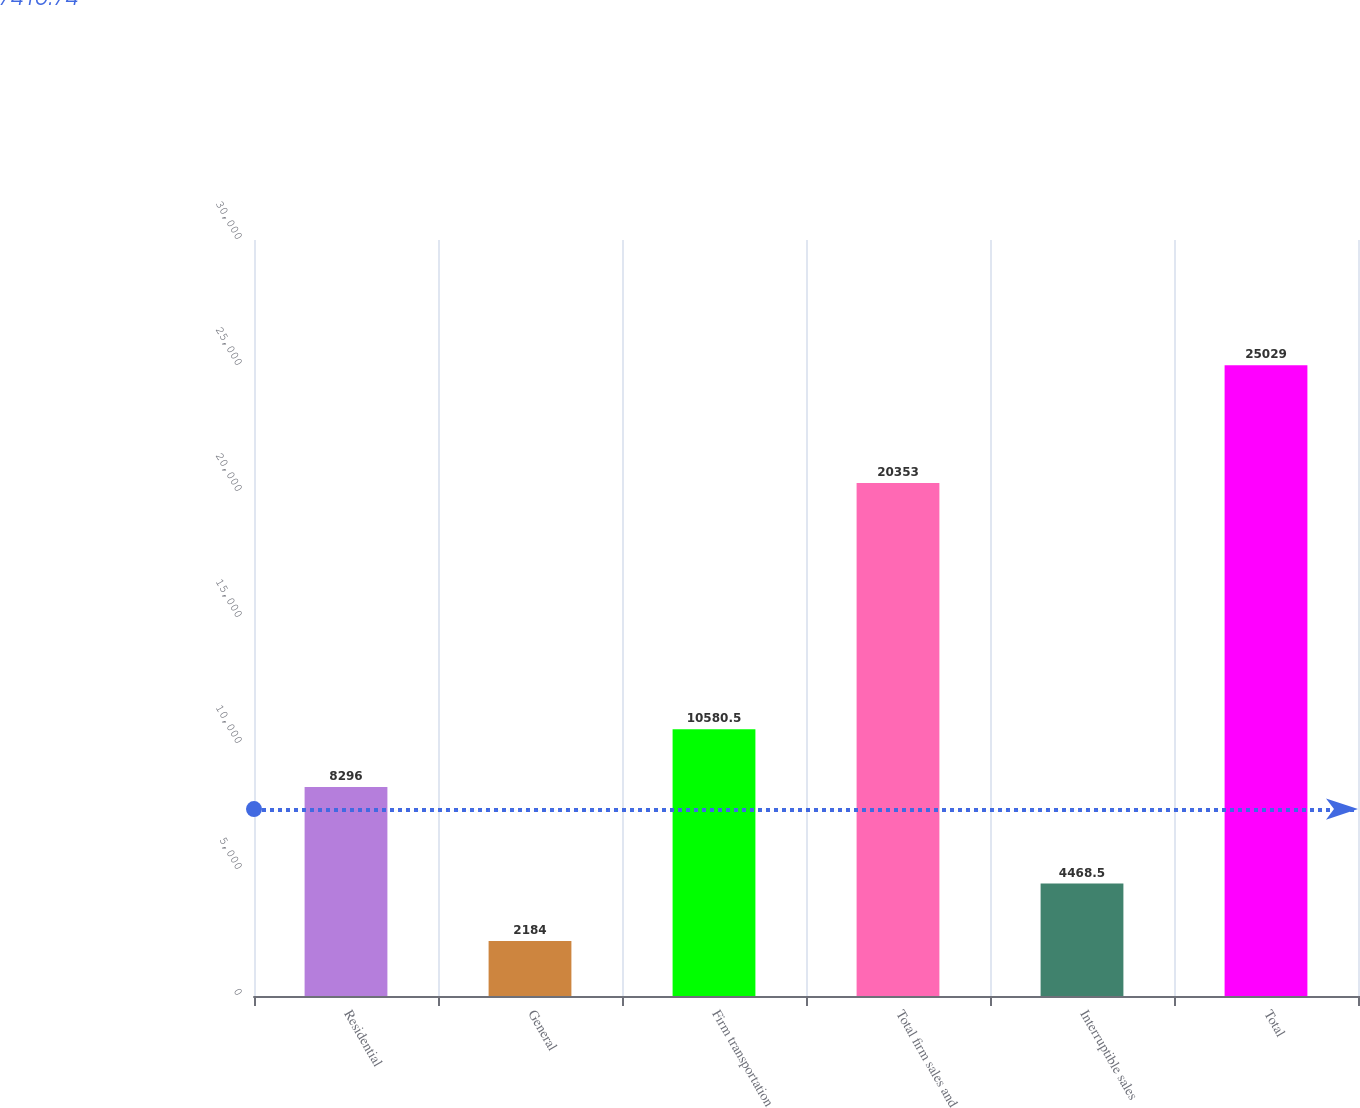<chart> <loc_0><loc_0><loc_500><loc_500><bar_chart><fcel>Residential<fcel>General<fcel>Firm transportation<fcel>Total firm sales and<fcel>Interruptible sales<fcel>Total<nl><fcel>8296<fcel>2184<fcel>10580.5<fcel>20353<fcel>4468.5<fcel>25029<nl></chart> 